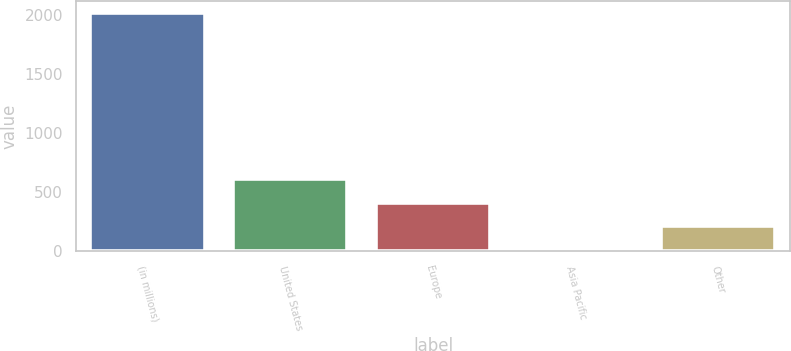<chart> <loc_0><loc_0><loc_500><loc_500><bar_chart><fcel>(in millions)<fcel>United States<fcel>Europe<fcel>Asia Pacific<fcel>Other<nl><fcel>2014<fcel>612.6<fcel>412.4<fcel>12<fcel>212.2<nl></chart> 